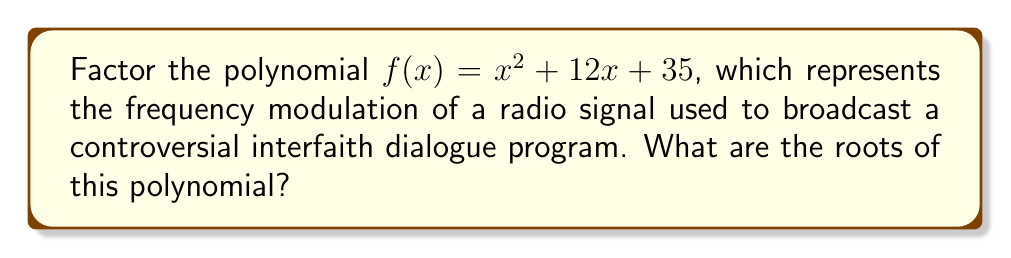Help me with this question. To factor this quadratic polynomial, we'll use the following steps:

1) The polynomial is in the form $ax^2 + bx + c$, where $a=1$, $b=12$, and $c=35$.

2) We need to find two numbers that multiply to give $ac = 1 * 35 = 35$ and add up to $b = 12$.

3) The numbers that satisfy this are 5 and 7, as $5 * 7 = 35$ and $5 + 7 = 12$.

4) We can rewrite the middle term using these numbers:
   $f(x) = x^2 + 5x + 7x + 35$

5) Group the terms:
   $f(x) = (x^2 + 5x) + (7x + 35)$

6) Factor out the common factors from each group:
   $f(x) = x(x + 5) + 7(x + 5)$

7) Factor out the common binomial $(x + 5)$:
   $f(x) = (x + 7)(x + 5)$

8) The roots of the polynomial are the values of $x$ that make each factor equal to zero:
   $x + 7 = 0$ or $x + 5 = 0$
   $x = -7$ or $x = -5$

These roots represent the frequencies at which the radio signal could be jammed to prevent the broadcast of the interfaith dialogue program.
Answer: $-7$ and $-5$ 